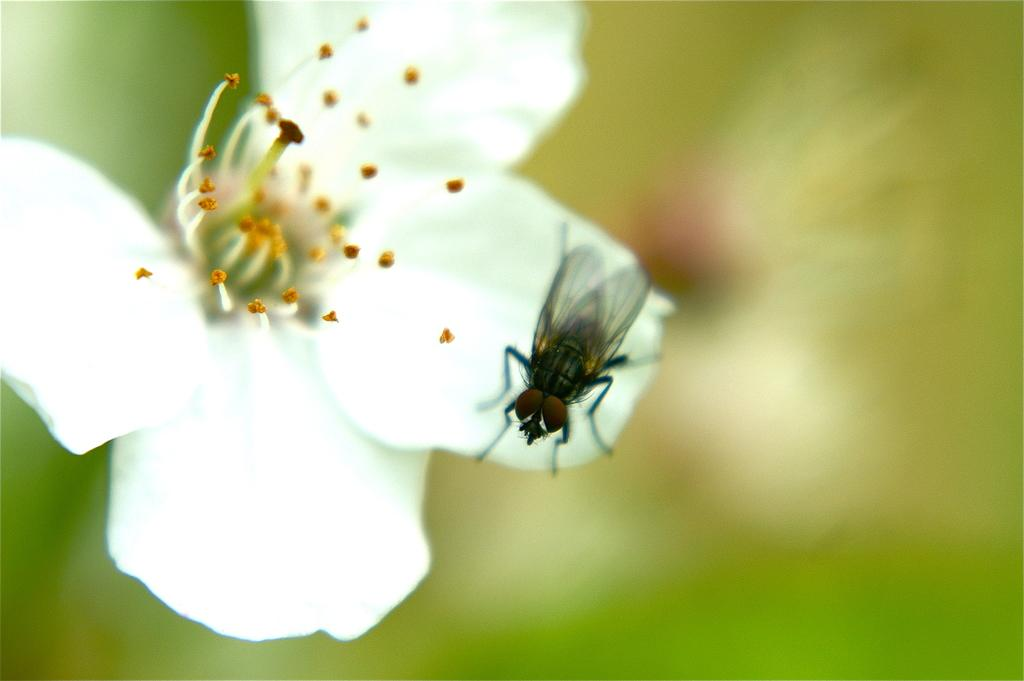What type of flower is in the image? There is a white color flower in the image. Are there any other living organisms present on the flower? Yes, there is a fly on the flower. What color is the background of the image? The background of the image is green. What type of body language does the flower exhibit when the fly lands on it? The flower does not exhibit body language, as it is a plant and not capable of such actions. 